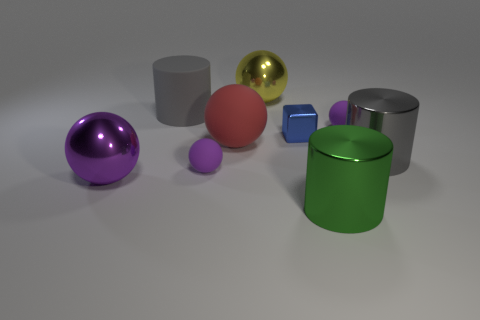How many purple balls must be subtracted to get 1 purple balls? 2 Subtract all big gray matte cylinders. How many cylinders are left? 2 Subtract all yellow balls. How many balls are left? 4 Subtract 1 balls. How many balls are left? 4 Subtract all gray cubes. How many purple balls are left? 3 Subtract 1 yellow balls. How many objects are left? 8 Subtract all spheres. How many objects are left? 4 Subtract all gray spheres. Subtract all purple cylinders. How many spheres are left? 5 Subtract all big gray metal things. Subtract all large metal objects. How many objects are left? 4 Add 1 rubber cylinders. How many rubber cylinders are left? 2 